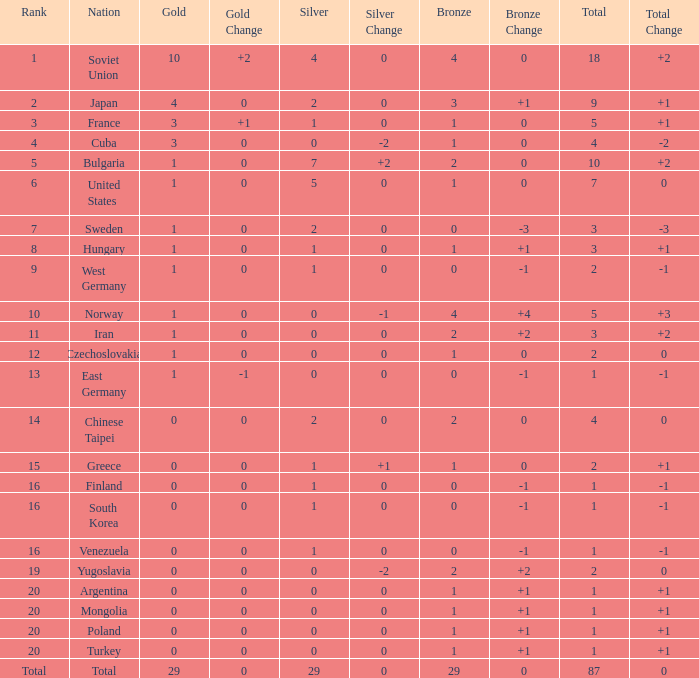What is the average number of bronze medals for total of all nations? 29.0. 